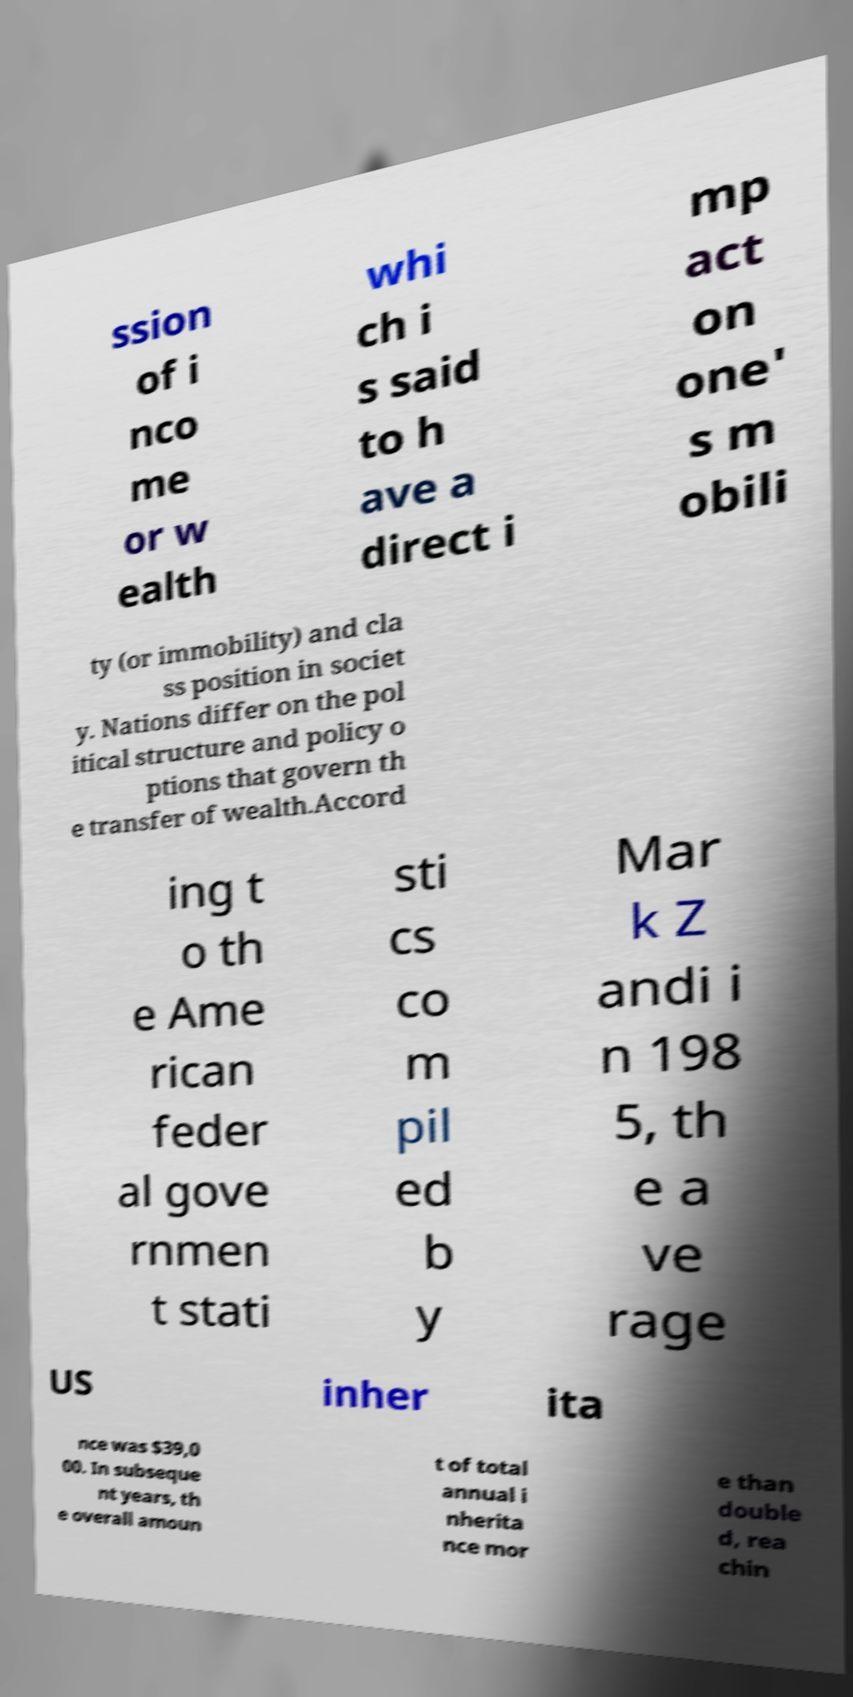Can you accurately transcribe the text from the provided image for me? ssion of i nco me or w ealth whi ch i s said to h ave a direct i mp act on one' s m obili ty (or immobility) and cla ss position in societ y. Nations differ on the pol itical structure and policy o ptions that govern th e transfer of wealth.Accord ing t o th e Ame rican feder al gove rnmen t stati sti cs co m pil ed b y Mar k Z andi i n 198 5, th e a ve rage US inher ita nce was $39,0 00. In subseque nt years, th e overall amoun t of total annual i nherita nce mor e than double d, rea chin 